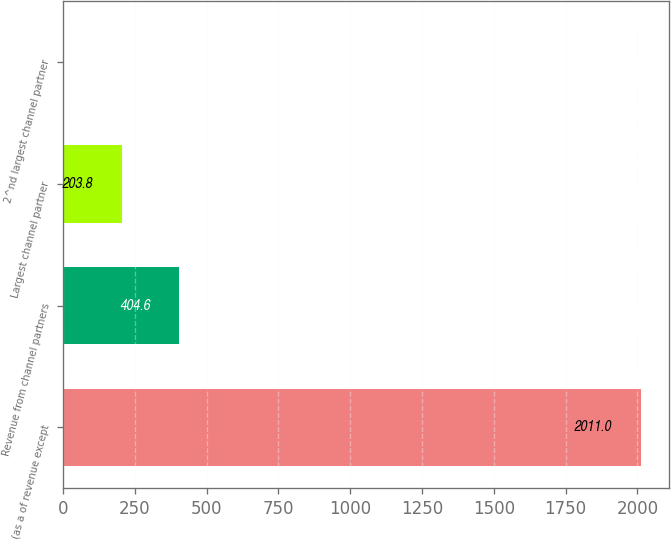Convert chart. <chart><loc_0><loc_0><loc_500><loc_500><bar_chart><fcel>(as a of revenue except<fcel>Revenue from channel partners<fcel>Largest channel partner<fcel>2^nd largest channel partner<nl><fcel>2011<fcel>404.6<fcel>203.8<fcel>3<nl></chart> 